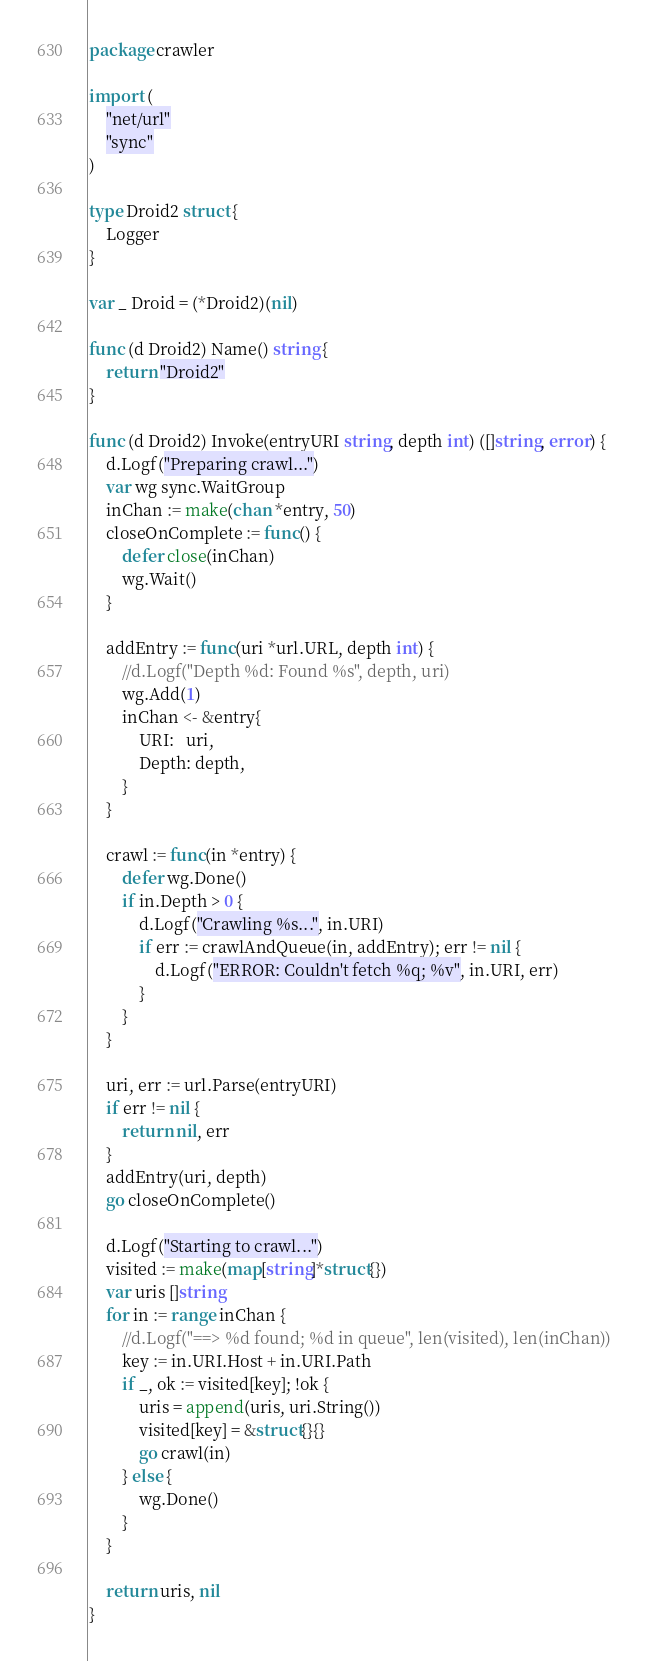Convert code to text. <code><loc_0><loc_0><loc_500><loc_500><_Go_>package crawler

import (
	"net/url"
	"sync"
)

type Droid2 struct {
	Logger
}

var _ Droid = (*Droid2)(nil)

func (d Droid2) Name() string {
	return "Droid2"
}

func (d Droid2) Invoke(entryURI string, depth int) ([]string, error) {
	d.Logf("Preparing crawl...")
	var wg sync.WaitGroup
	inChan := make(chan *entry, 50)
	closeOnComplete := func() {
		defer close(inChan)
		wg.Wait()
	}

	addEntry := func(uri *url.URL, depth int) {
		//d.Logf("Depth %d: Found %s", depth, uri)
		wg.Add(1)
		inChan <- &entry{
			URI:   uri,
			Depth: depth,
		}
	}

	crawl := func(in *entry) {
		defer wg.Done()
		if in.Depth > 0 {
			d.Logf("Crawling %s...", in.URI)
			if err := crawlAndQueue(in, addEntry); err != nil {
				d.Logf("ERROR: Couldn't fetch %q; %v", in.URI, err)
			}
		}
	}

	uri, err := url.Parse(entryURI)
	if err != nil {
		return nil, err
	}
	addEntry(uri, depth)
	go closeOnComplete()

	d.Logf("Starting to crawl...")
	visited := make(map[string]*struct{})
	var uris []string
	for in := range inChan {
		//d.Logf("==> %d found; %d in queue", len(visited), len(inChan))
		key := in.URI.Host + in.URI.Path
		if _, ok := visited[key]; !ok {
			uris = append(uris, uri.String())
			visited[key] = &struct{}{}
			go crawl(in)
		} else {
			wg.Done()
		}
	}

	return uris, nil
}
</code> 